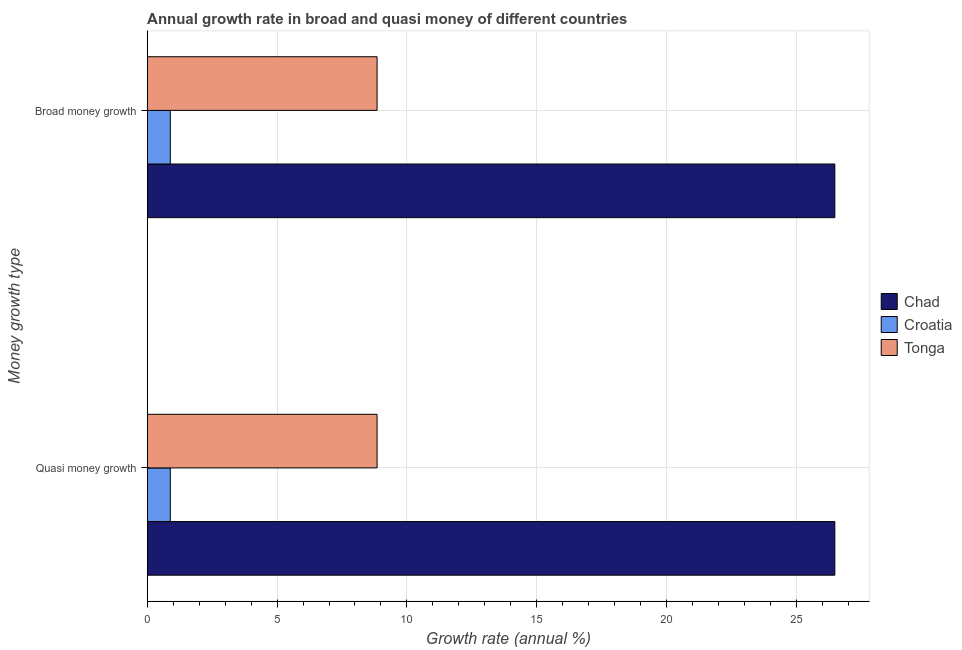How many different coloured bars are there?
Ensure brevity in your answer.  3. Are the number of bars per tick equal to the number of legend labels?
Your response must be concise. Yes. Are the number of bars on each tick of the Y-axis equal?
Offer a very short reply. Yes. How many bars are there on the 1st tick from the bottom?
Give a very brief answer. 3. What is the label of the 2nd group of bars from the top?
Make the answer very short. Quasi money growth. What is the annual growth rate in quasi money in Chad?
Offer a terse response. 26.48. Across all countries, what is the maximum annual growth rate in broad money?
Ensure brevity in your answer.  26.48. Across all countries, what is the minimum annual growth rate in quasi money?
Offer a very short reply. 0.89. In which country was the annual growth rate in broad money maximum?
Give a very brief answer. Chad. In which country was the annual growth rate in quasi money minimum?
Provide a succinct answer. Croatia. What is the total annual growth rate in broad money in the graph?
Give a very brief answer. 36.22. What is the difference between the annual growth rate in quasi money in Croatia and that in Chad?
Your answer should be compact. -25.58. What is the difference between the annual growth rate in broad money in Chad and the annual growth rate in quasi money in Croatia?
Your answer should be compact. 25.58. What is the average annual growth rate in quasi money per country?
Your answer should be very brief. 12.07. In how many countries, is the annual growth rate in broad money greater than 4 %?
Your answer should be very brief. 2. What is the ratio of the annual growth rate in broad money in Chad to that in Croatia?
Make the answer very short. 29.72. Is the annual growth rate in quasi money in Chad less than that in Tonga?
Your answer should be compact. No. What does the 1st bar from the top in Quasi money growth represents?
Give a very brief answer. Tonga. What does the 1st bar from the bottom in Quasi money growth represents?
Your answer should be very brief. Chad. Are all the bars in the graph horizontal?
Provide a succinct answer. Yes. How many countries are there in the graph?
Your answer should be compact. 3. Does the graph contain any zero values?
Your response must be concise. No. What is the title of the graph?
Keep it short and to the point. Annual growth rate in broad and quasi money of different countries. What is the label or title of the X-axis?
Ensure brevity in your answer.  Growth rate (annual %). What is the label or title of the Y-axis?
Your response must be concise. Money growth type. What is the Growth rate (annual %) in Chad in Quasi money growth?
Ensure brevity in your answer.  26.48. What is the Growth rate (annual %) in Croatia in Quasi money growth?
Offer a very short reply. 0.89. What is the Growth rate (annual %) in Tonga in Quasi money growth?
Your response must be concise. 8.85. What is the Growth rate (annual %) in Chad in Broad money growth?
Your response must be concise. 26.48. What is the Growth rate (annual %) of Croatia in Broad money growth?
Your answer should be compact. 0.89. What is the Growth rate (annual %) in Tonga in Broad money growth?
Keep it short and to the point. 8.85. Across all Money growth type, what is the maximum Growth rate (annual %) of Chad?
Your answer should be compact. 26.48. Across all Money growth type, what is the maximum Growth rate (annual %) of Croatia?
Make the answer very short. 0.89. Across all Money growth type, what is the maximum Growth rate (annual %) of Tonga?
Provide a short and direct response. 8.85. Across all Money growth type, what is the minimum Growth rate (annual %) in Chad?
Your answer should be compact. 26.48. Across all Money growth type, what is the minimum Growth rate (annual %) of Croatia?
Your answer should be compact. 0.89. Across all Money growth type, what is the minimum Growth rate (annual %) in Tonga?
Your answer should be very brief. 8.85. What is the total Growth rate (annual %) of Chad in the graph?
Give a very brief answer. 52.95. What is the total Growth rate (annual %) of Croatia in the graph?
Keep it short and to the point. 1.78. What is the total Growth rate (annual %) in Tonga in the graph?
Your response must be concise. 17.7. What is the difference between the Growth rate (annual %) of Chad in Quasi money growth and that in Broad money growth?
Make the answer very short. 0. What is the difference between the Growth rate (annual %) in Tonga in Quasi money growth and that in Broad money growth?
Your response must be concise. 0. What is the difference between the Growth rate (annual %) in Chad in Quasi money growth and the Growth rate (annual %) in Croatia in Broad money growth?
Provide a short and direct response. 25.58. What is the difference between the Growth rate (annual %) of Chad in Quasi money growth and the Growth rate (annual %) of Tonga in Broad money growth?
Your response must be concise. 17.62. What is the difference between the Growth rate (annual %) of Croatia in Quasi money growth and the Growth rate (annual %) of Tonga in Broad money growth?
Make the answer very short. -7.96. What is the average Growth rate (annual %) in Chad per Money growth type?
Provide a short and direct response. 26.48. What is the average Growth rate (annual %) of Croatia per Money growth type?
Offer a terse response. 0.89. What is the average Growth rate (annual %) of Tonga per Money growth type?
Your answer should be very brief. 8.85. What is the difference between the Growth rate (annual %) in Chad and Growth rate (annual %) in Croatia in Quasi money growth?
Offer a terse response. 25.58. What is the difference between the Growth rate (annual %) of Chad and Growth rate (annual %) of Tonga in Quasi money growth?
Give a very brief answer. 17.62. What is the difference between the Growth rate (annual %) of Croatia and Growth rate (annual %) of Tonga in Quasi money growth?
Your response must be concise. -7.96. What is the difference between the Growth rate (annual %) in Chad and Growth rate (annual %) in Croatia in Broad money growth?
Offer a very short reply. 25.58. What is the difference between the Growth rate (annual %) of Chad and Growth rate (annual %) of Tonga in Broad money growth?
Provide a succinct answer. 17.62. What is the difference between the Growth rate (annual %) in Croatia and Growth rate (annual %) in Tonga in Broad money growth?
Your answer should be very brief. -7.96. What is the ratio of the Growth rate (annual %) of Chad in Quasi money growth to that in Broad money growth?
Offer a terse response. 1. What is the ratio of the Growth rate (annual %) in Croatia in Quasi money growth to that in Broad money growth?
Offer a very short reply. 1. What is the ratio of the Growth rate (annual %) in Tonga in Quasi money growth to that in Broad money growth?
Offer a very short reply. 1. What is the difference between the highest and the second highest Growth rate (annual %) in Croatia?
Your response must be concise. 0. What is the difference between the highest and the lowest Growth rate (annual %) of Croatia?
Your response must be concise. 0. What is the difference between the highest and the lowest Growth rate (annual %) of Tonga?
Your answer should be very brief. 0. 